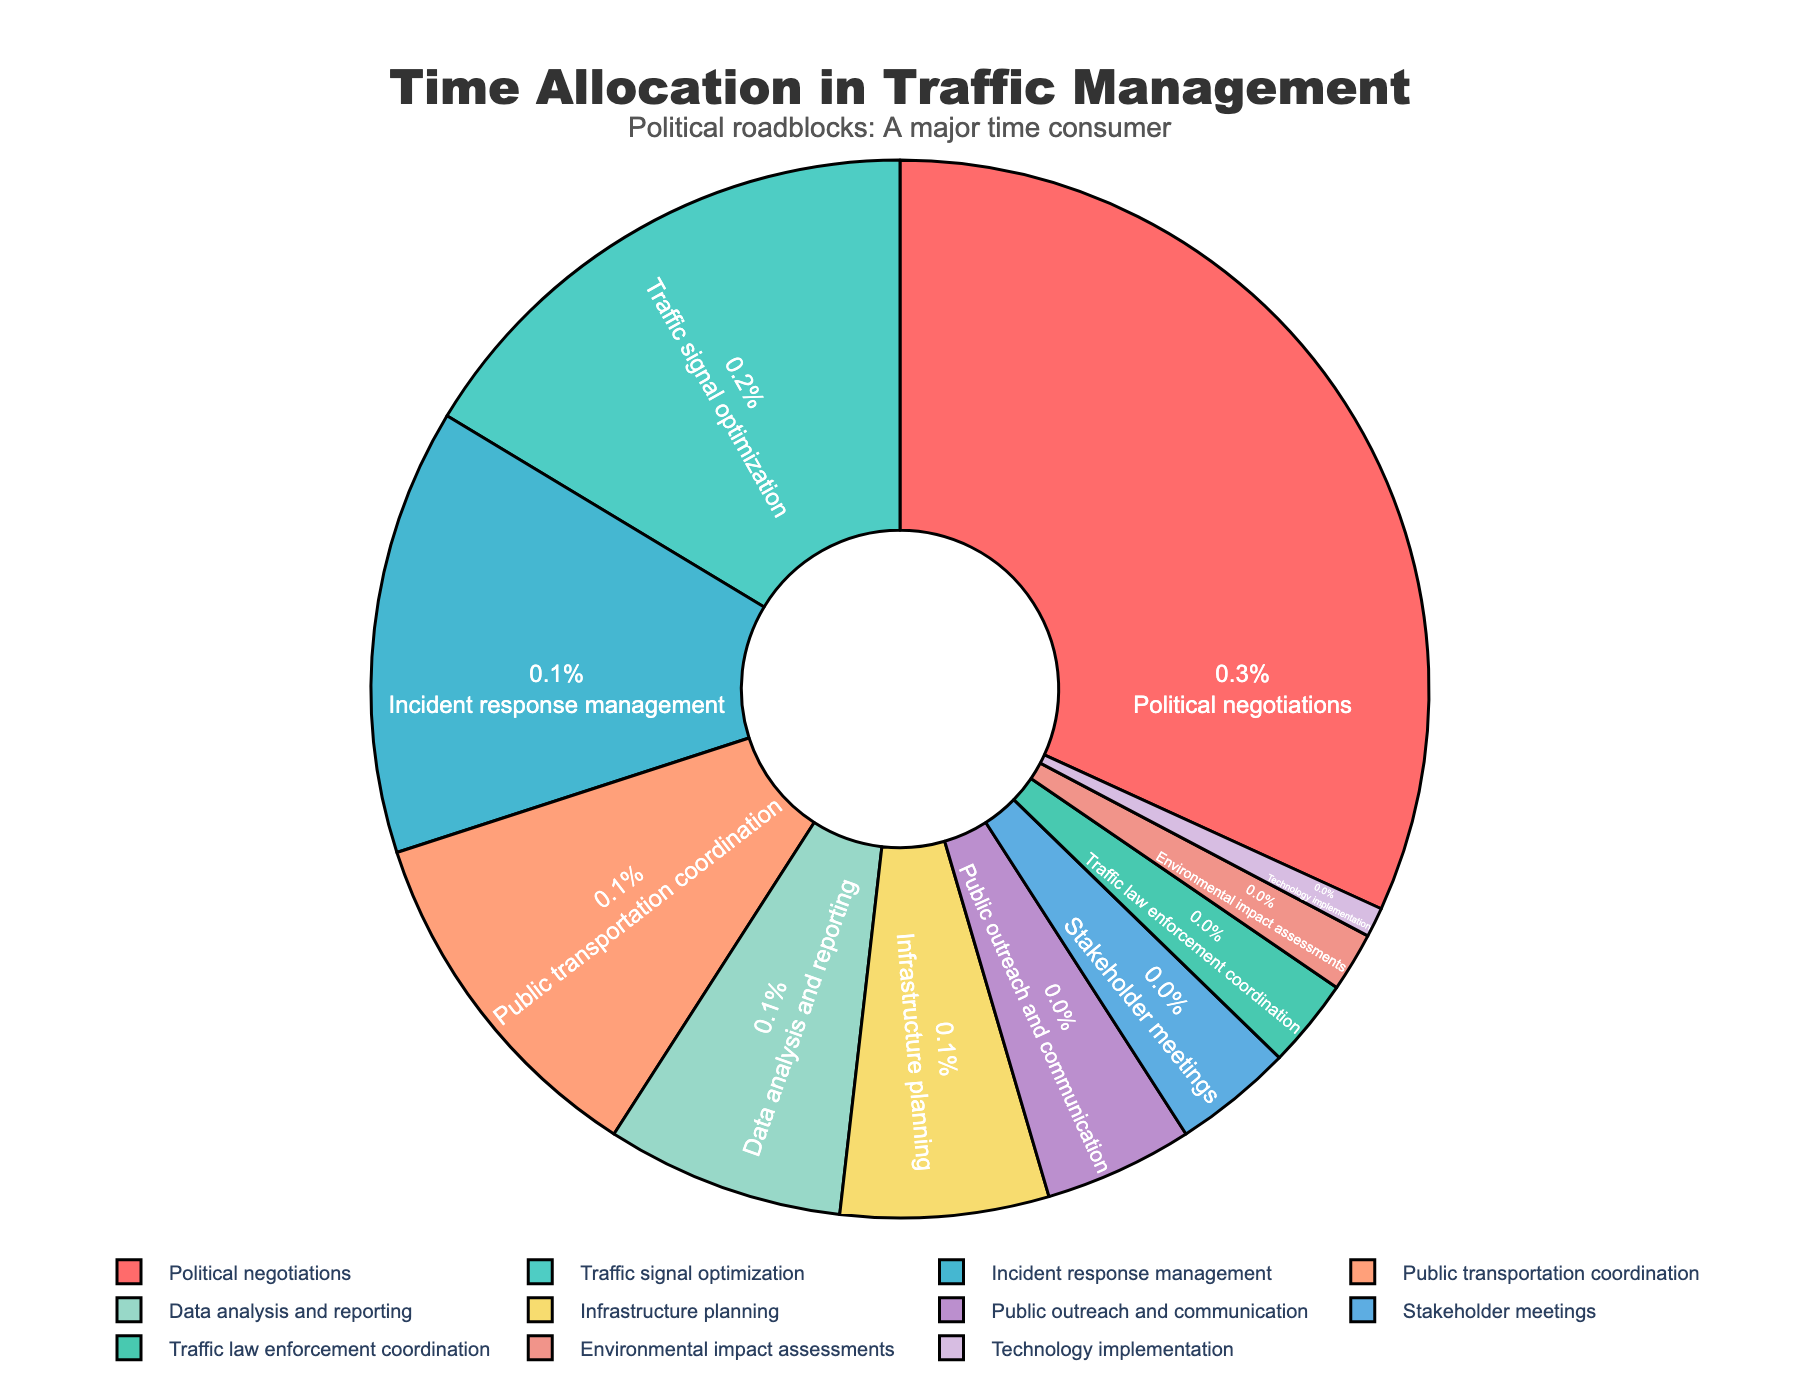Which task takes up the most time according to the pie chart? The largest portion of the pie chart is labeled "Political negotiations," indicating that it occupies the most percentage of time.
Answer: Political negotiations What is the total percentage of time spent on Public transportation coordination and Incident response management? According to the chart, Public transportation coordination takes up 12% and Incident response management takes up 15%. Summing these up gives 12% + 15% = 27%.
Answer: 27% Which task takes up less time: Infrastructure planning or Data analysis and reporting? The pie chart shows "Infrastructure planning" with 7% and "Data analysis and reporting" with 8%. Since 7% is less than 8%, Infrastructure planning takes up less time.
Answer: Infrastructure planning How much more time is spent on Traffic signal optimization compared to Traffic law enforcement coordination? Traffic signal optimization takes up 18% while Traffic law enforcement coordination takes up 3%. The difference is 18% - 3% = 15%.
Answer: 15% What tasks together make up 42% of the time? From the pie chart, Political negotiations (35%) and Stakeholder meetings (4%) can add up to 35% + 4% = 39%. Adding Technology implementation (1%) brings the total to 40%. Adding Environmental impact assessments (2%) then gives 40% + 2% = 42%.
Answer: Political negotiations, Stakeholder meetings, Technology implementation, and Environmental impact assessments Which two tasks combined take up the same amount of time as Political negotiations? Political negotiations take up 35%. From the pie chart, 18% (Traffic signal optimization) and 15% (Incident response management) together make up 18% + 15% = 33%, which is very close but not exactly 35%. Instead, combining 15% (Incident response management), 12% (Public transportation coordination), and 8% (Data analysis and reporting) gives us 15% + 12% + 8% = 35%.
Answer: Incident response management, Public transportation coordination, and Data analysis and reporting What task takes up exactly the same percentage of time as Environmental impact assessments? According to the pie chart, Environmental impact assessments take up 2%. There is no other task with exactly the same percentage on this chart.
Answer: None Is the percentage of time spent on Public outreach and communication more or less than double the time spent on Technology implementation? Public outreach and communication is 5%, and Technology implementation is 1%. Double the time spent on Technology implementation is 1% * 2 = 2%. Since 5% is more than 2%, Public outreach and communication takes up more time.
Answer: More 